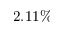<formula> <loc_0><loc_0><loc_500><loc_500>2 . 1 1 \%</formula> 